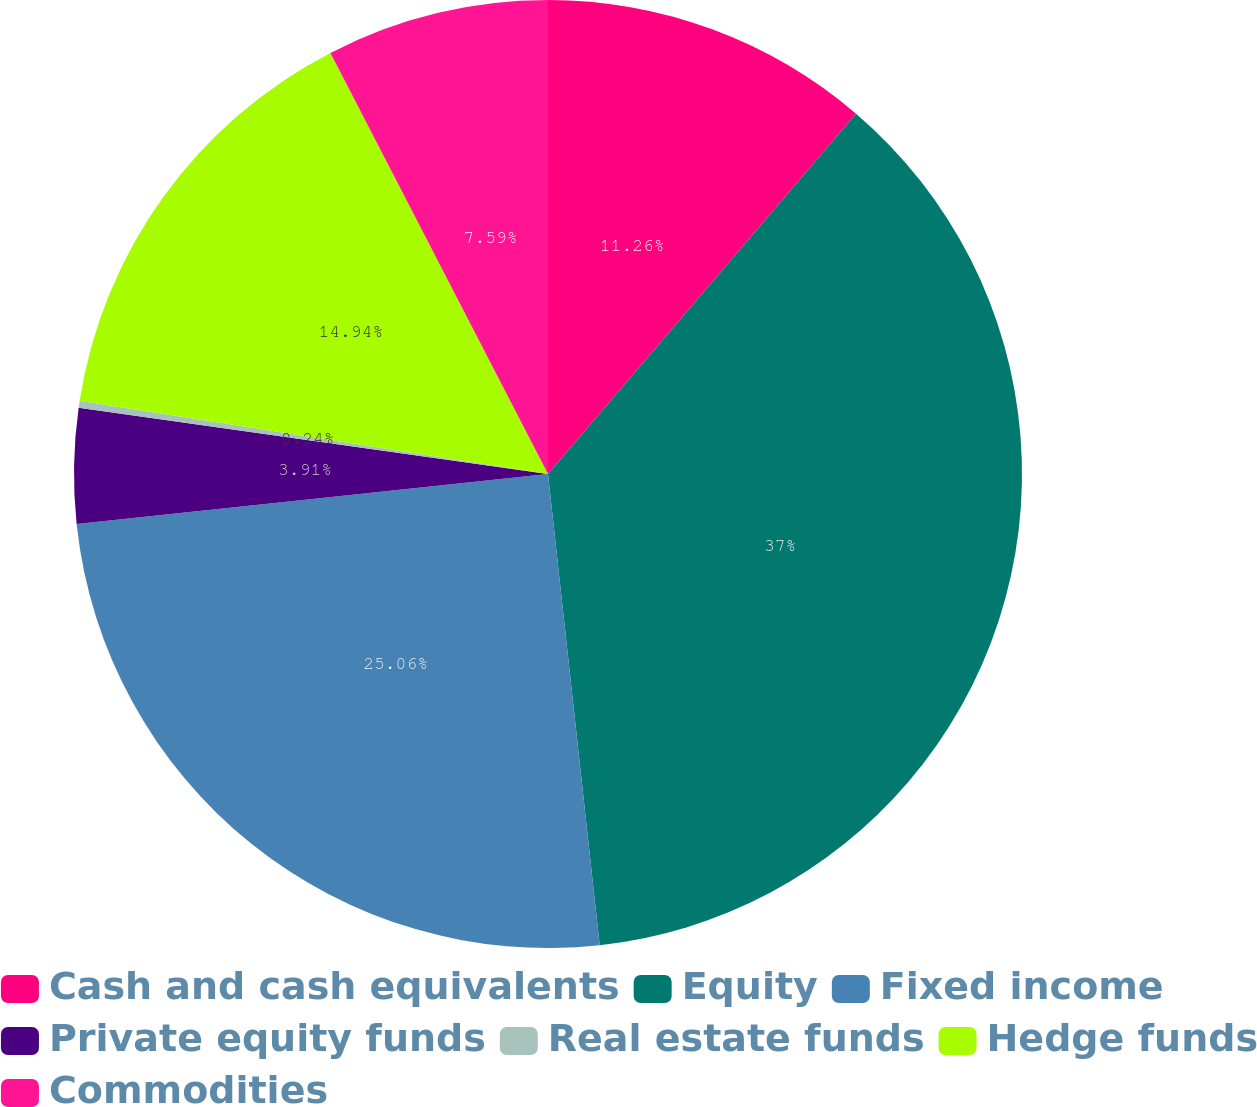Convert chart. <chart><loc_0><loc_0><loc_500><loc_500><pie_chart><fcel>Cash and cash equivalents<fcel>Equity<fcel>Fixed income<fcel>Private equity funds<fcel>Real estate funds<fcel>Hedge funds<fcel>Commodities<nl><fcel>11.26%<fcel>37.0%<fcel>25.06%<fcel>3.91%<fcel>0.24%<fcel>14.94%<fcel>7.59%<nl></chart> 